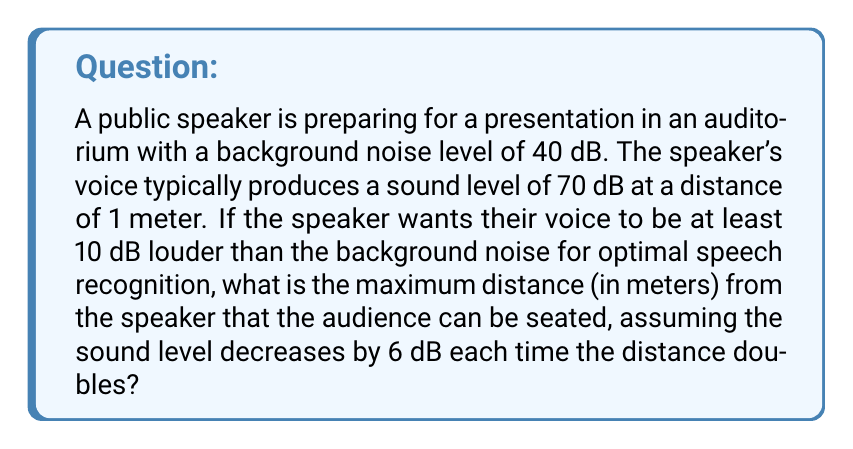What is the answer to this math problem? Let's approach this step-by-step:

1) First, we need to determine the minimum sound level required for the speaker's voice:
   Background noise level = 40 dB
   Required difference = 10 dB
   Minimum speaker sound level = 40 dB + 10 dB = 50 dB

2) The speaker's voice is 70 dB at 1 meter. We need to find how far this can decrease to 50 dB.
   Total decrease needed = 70 dB - 50 dB = 20 dB

3) We're told that the sound level decreases by 6 dB each time the distance doubles. Let's express this mathematically:
   
   If $d$ is the distance and $n$ is the number of times the distance doubles:
   $d = 2^n$ meters
   Decrease in dB = $6n$ dB

4) We want the decrease to be 20 dB, so:
   $6n = 20$
   $n = \frac{20}{6} = \frac{10}{3} \approx 3.33$

5) Now we can calculate the distance:
   $d = 2^{\frac{10}{3}} \approx 10.08$ meters

Therefore, the maximum distance is approximately 10.08 meters.
Answer: 10.08 meters 